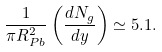Convert formula to latex. <formula><loc_0><loc_0><loc_500><loc_500>\frac { 1 } { \pi R _ { P b } ^ { 2 } } \left ( \frac { d N _ { g } } { d y } \right ) \simeq 5 . 1 .</formula> 